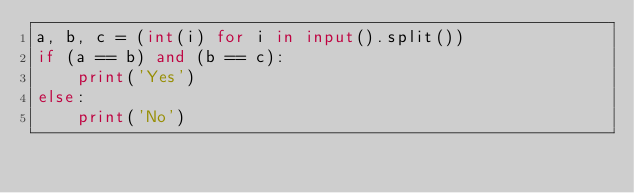Convert code to text. <code><loc_0><loc_0><loc_500><loc_500><_Python_>a, b, c = (int(i) for i in input().split())  
if (a == b) and (b == c):
    print('Yes')
else:
    print('No')</code> 